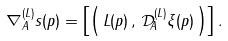Convert formula to latex. <formula><loc_0><loc_0><loc_500><loc_500>\nabla _ { A } ^ { ( L ) } s ( p ) = \left [ \left ( \, L ( p ) \, , \, \mathcal { D } _ { A } ^ { ( L ) } \xi ( p ) \, \right ) \right ] .</formula> 